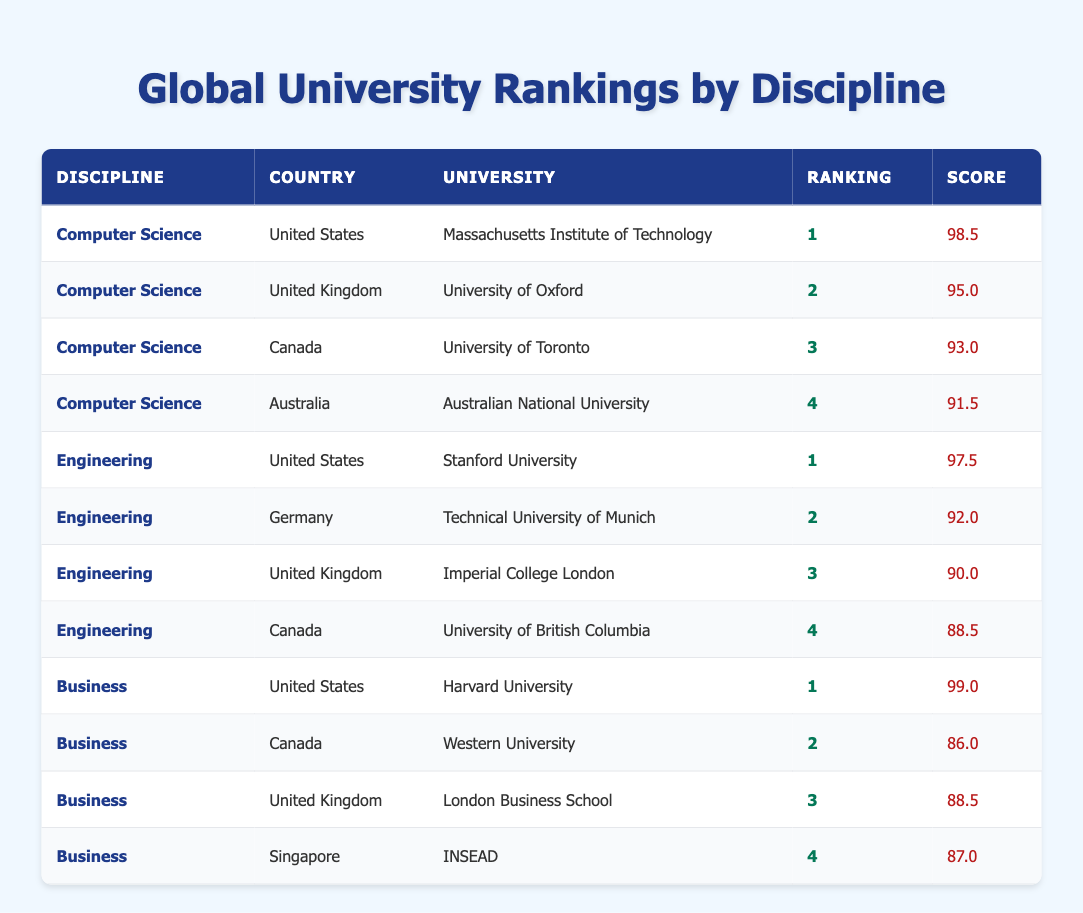What is the highest-ranked university for Computer Science? The table shows that the Massachusetts Institute of Technology is ranked 1 for Computer Science with a score of 98.5.
Answer: Massachusetts Institute of Technology Which Canadian university is ranked the highest in Engineering? According to the table, the University of British Columbia is ranked 4 in Engineering for Canada, which is the highest rank among Canadian universities listed in this discipline.
Answer: University of British Columbia Is the University of Oxford ranked higher than the University of Toronto in Computer Science? The table indicates that the University of Oxford is ranked 2 in Computer Science, whereas the University of Toronto is ranked 3. Therefore, the University of Oxford is indeed ranked higher.
Answer: Yes What is the average score of the top 3 universities in Business? The scores of the top 3 universities in Business are 99.0 (Harvard University), 88.5 (London Business School), and 86.0 (Western University). Summing these gives 99.0 + 88.5 + 86.0 = 273.5, and dividing by 3 gives an average of 91.17.
Answer: 91.17 Which discipline has the university with the highest score overall? The highest score in the table is 99.0 for Harvard University in the Business discipline. This score is greater than any score in Computer Science or Engineering.
Answer: Business Does Canada have a university in the top 3 for Computer Science? The table shows that the University of Toronto is ranked 3 in Computer Science. Therefore, Canada does have a university in the top 3 for this discipline.
Answer: Yes What is the difference in score between the highest-ranked university in Engineering and the highest-ranked university in Business? The highest-ranked university in Engineering is Stanford University with a score of 97.5. The highest-ranked university in Business is Harvard University with a score of 99.0. The difference is 99.0 - 97.5 = 1.5.
Answer: 1.5 Which country has the highest representation in the top rankings across all disciplines? The table shows multiple rankings across doctrines: USA (2), Canada (2), UK (3). The largest representation is from the United States, with 4 entries: 2 in Computer Science and 1 each in Engineering and Business.
Answer: United States What is the lowest rank of a Canadian university in the table? The lowest-ranking Canadian university listed is Western University, which ranks 2 in Business. There are no higher-ranked entries for Canadian institutions in the other disciplines.
Answer: 2 